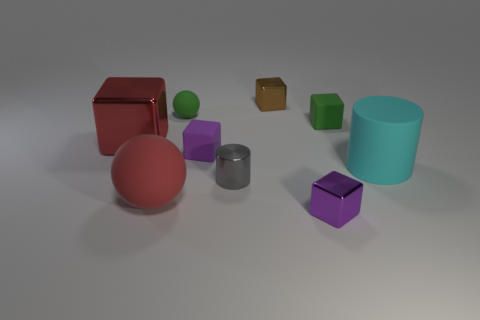Are the purple object to the left of the gray metallic object and the small purple cube right of the small cylinder made of the same material?
Your answer should be very brief. No. What is the small brown cube made of?
Make the answer very short. Metal. How many gray shiny things have the same shape as the brown metallic thing?
Keep it short and to the point. 0. There is a ball that is the same color as the big metallic cube; what is it made of?
Provide a short and direct response. Rubber. Are there any other things that are the same shape as the brown object?
Provide a short and direct response. Yes. What is the color of the rubber sphere that is behind the large rubber thing to the left of the tiny purple thing in front of the gray object?
Give a very brief answer. Green. How many small objects are green rubber cylinders or cyan cylinders?
Offer a very short reply. 0. Are there the same number of large matte objects that are to the left of the brown metallic cube and tiny yellow rubber objects?
Provide a succinct answer. No. Are there any big spheres behind the large matte cylinder?
Provide a short and direct response. No. How many rubber objects are either tiny things or small cyan cylinders?
Give a very brief answer. 3. 